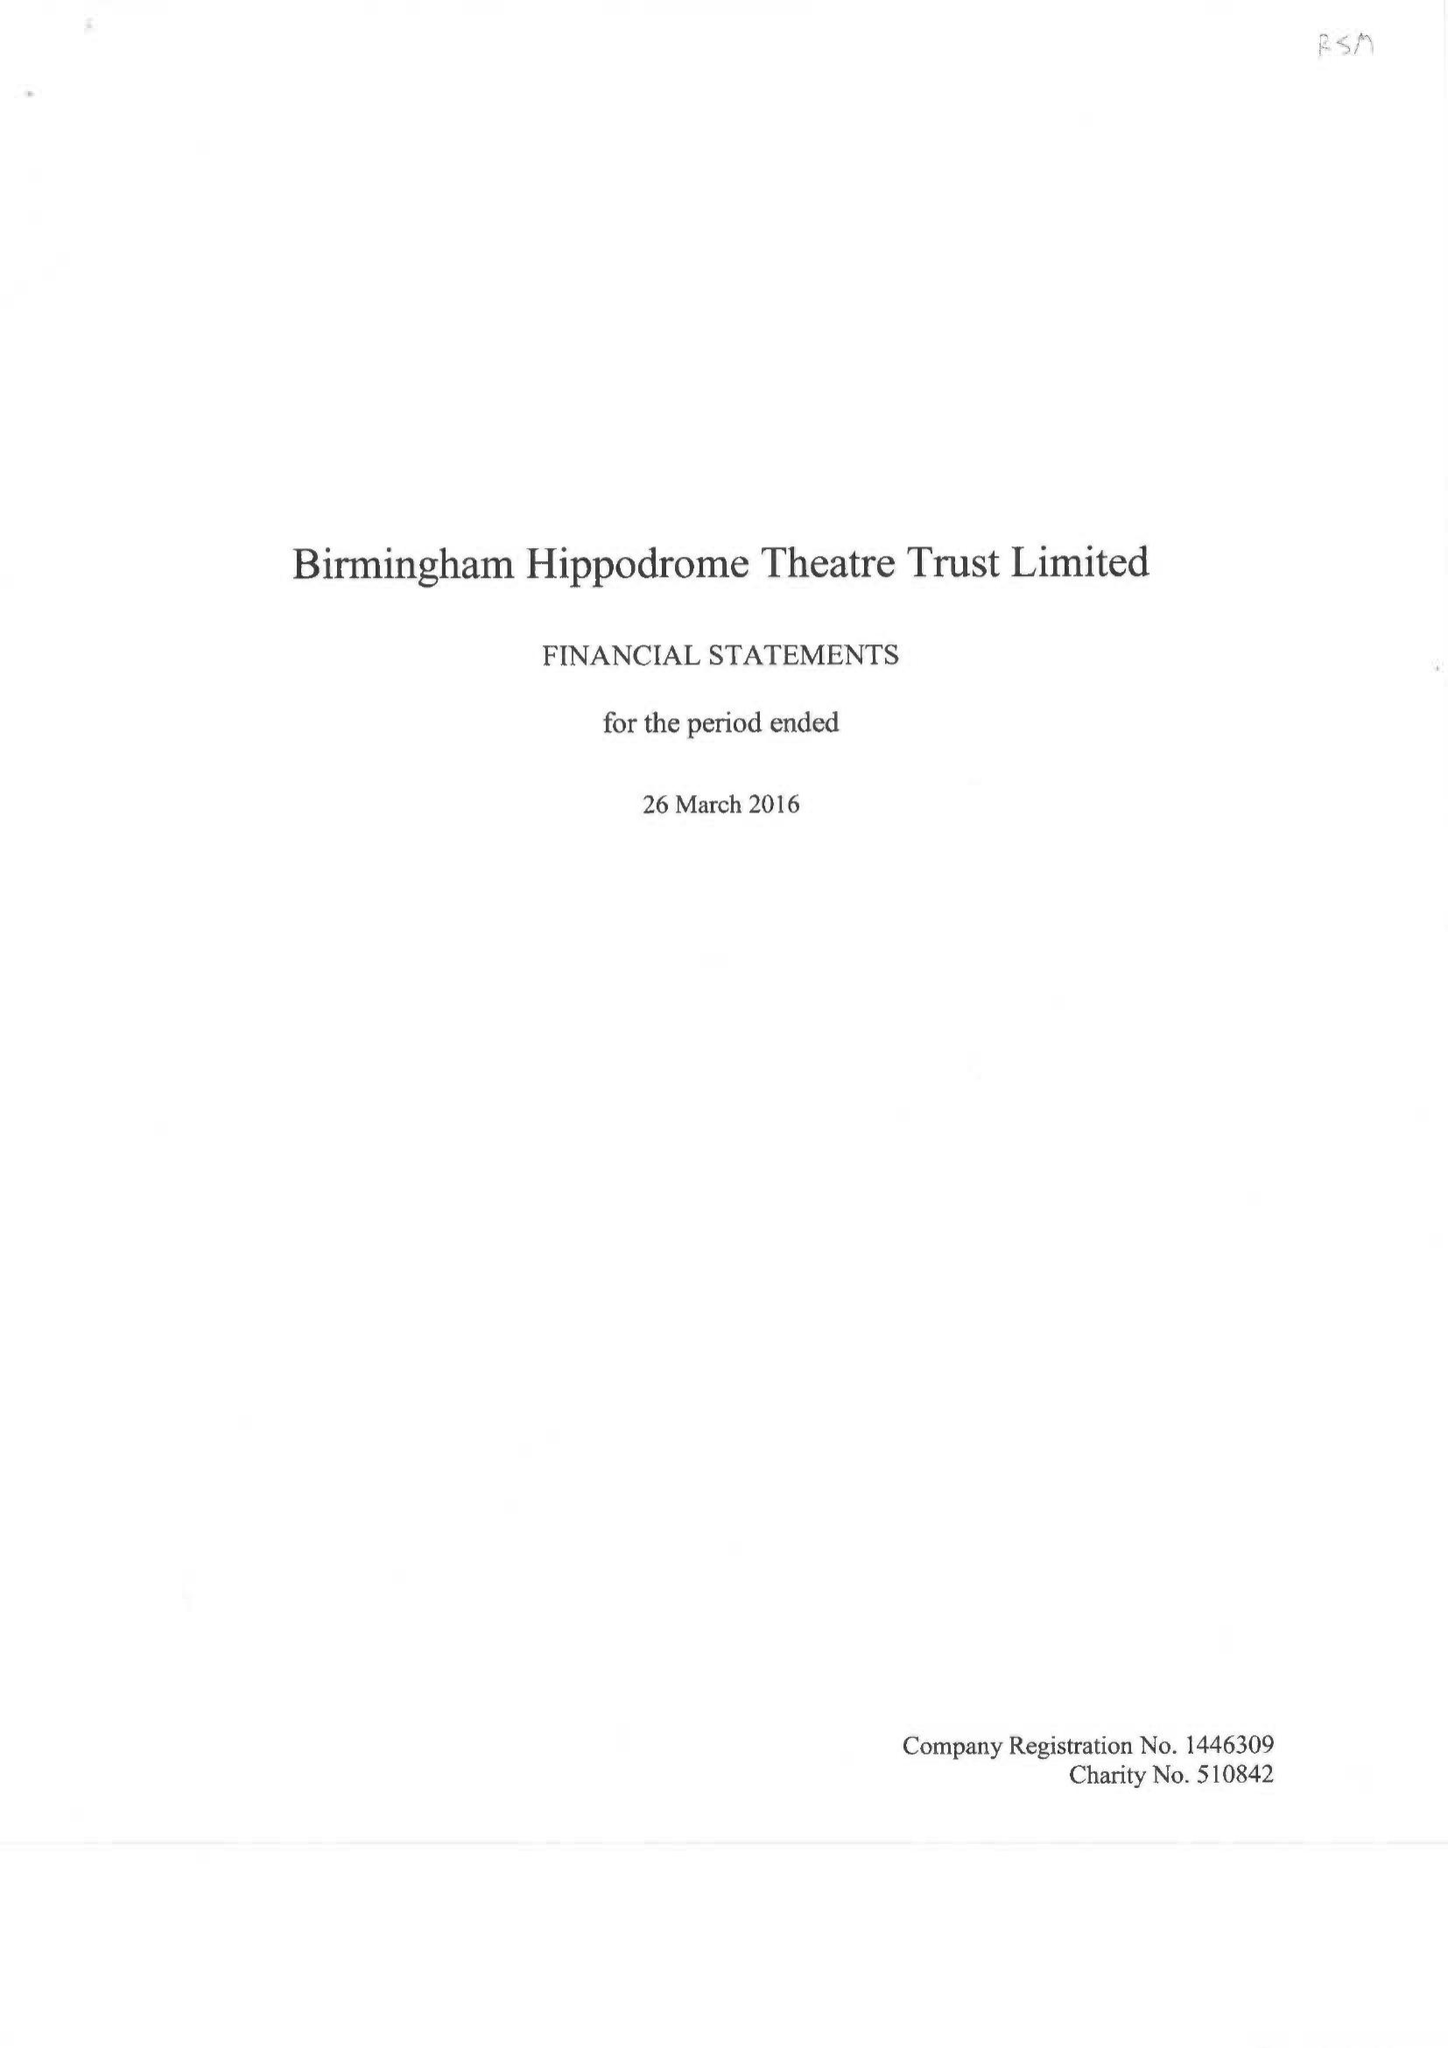What is the value for the charity_name?
Answer the question using a single word or phrase. Birmingham Hippodrome Theatre Trust Ltd. 